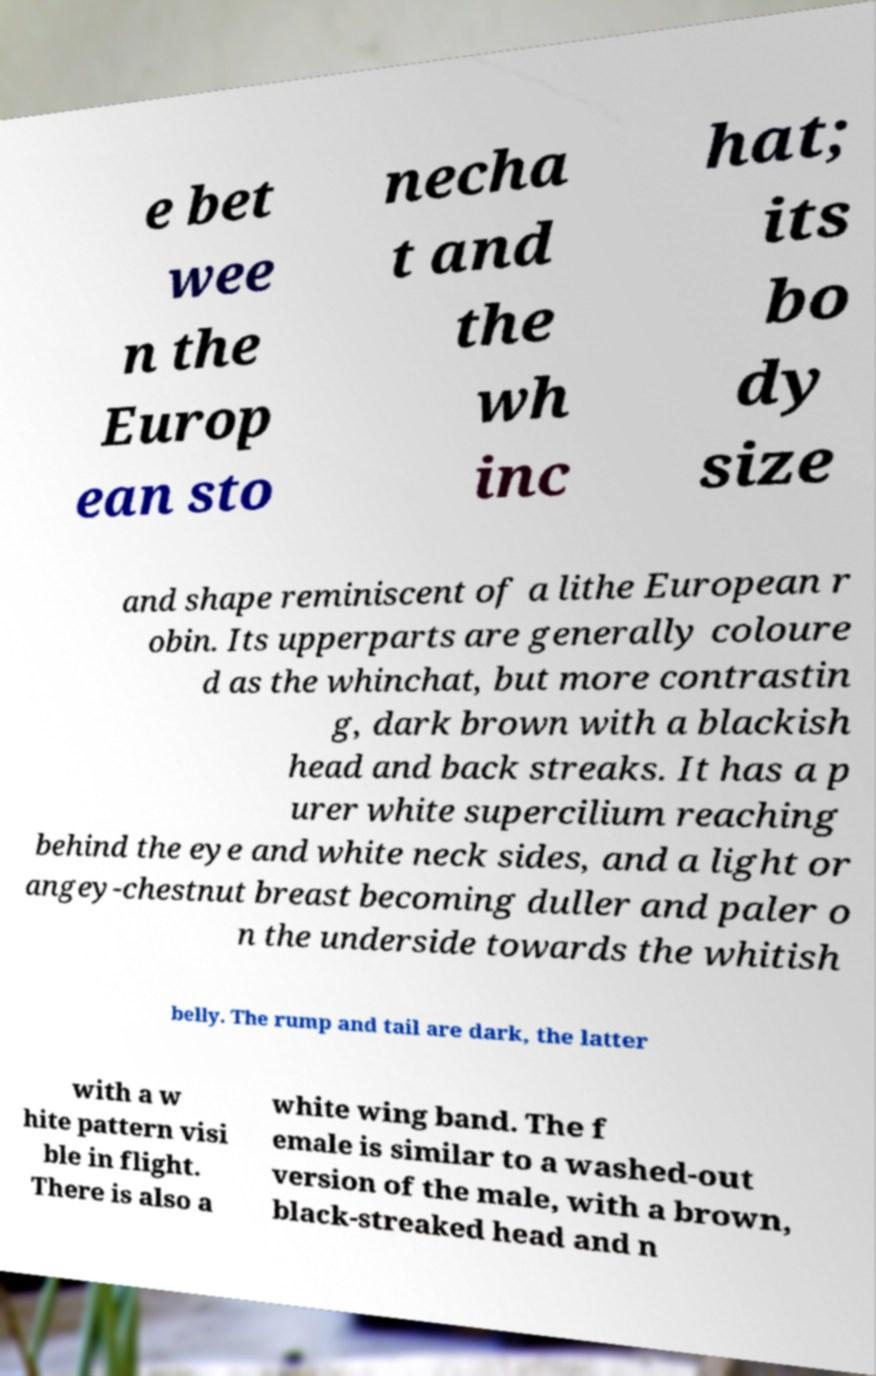Could you assist in decoding the text presented in this image and type it out clearly? e bet wee n the Europ ean sto necha t and the wh inc hat; its bo dy size and shape reminiscent of a lithe European r obin. Its upperparts are generally coloure d as the whinchat, but more contrastin g, dark brown with a blackish head and back streaks. It has a p urer white supercilium reaching behind the eye and white neck sides, and a light or angey-chestnut breast becoming duller and paler o n the underside towards the whitish belly. The rump and tail are dark, the latter with a w hite pattern visi ble in flight. There is also a white wing band. The f emale is similar to a washed-out version of the male, with a brown, black-streaked head and n 